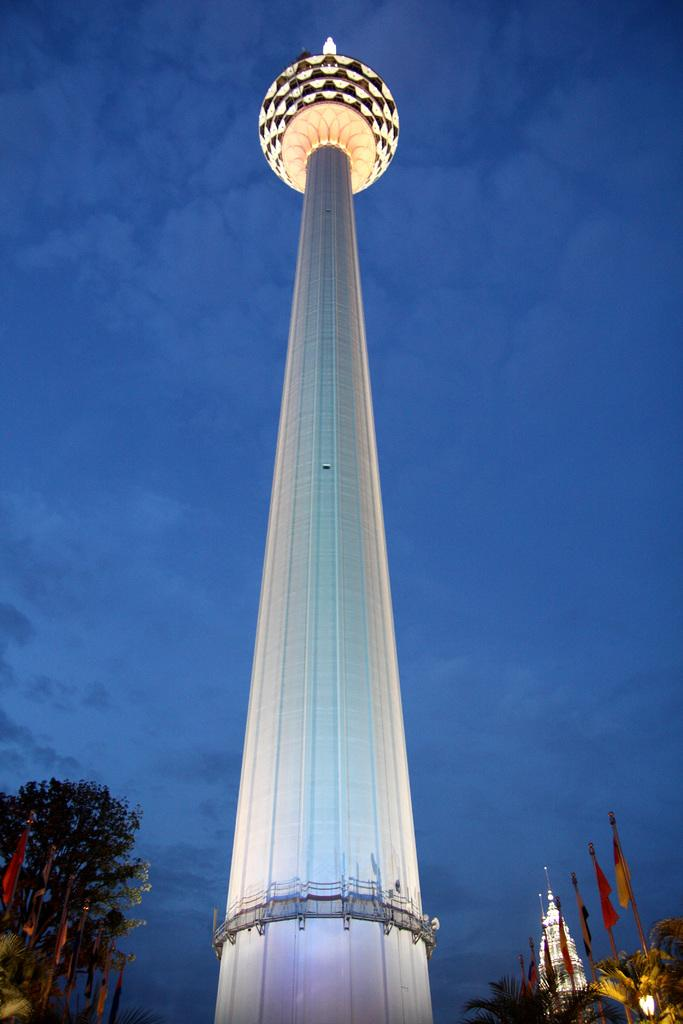What is the main structure in the picture? There is a tower in the picture. What type of vegetation is present in the picture? There are trees in the picture. What additional elements can be seen in the picture? There are flags in the picture. What is the condition of the sky in the picture? The sky is clear in the picture. What type of yoke is being used by the slaves in the picture? There are no slaves or yokes present in the image; it features a tower, trees, and flags. What type of juice can be seen being served in the picture? There is no juice or serving activity present in the image. 